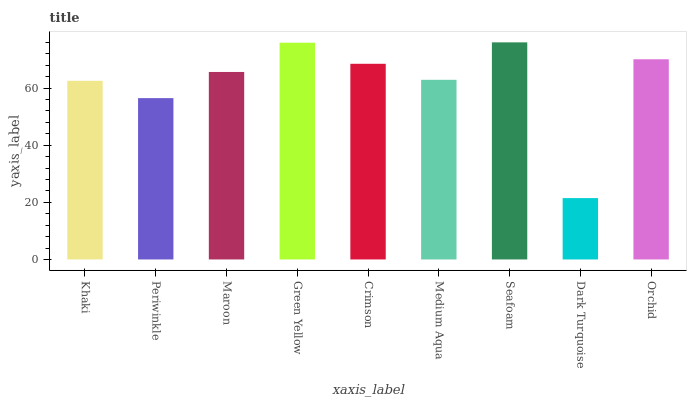Is Dark Turquoise the minimum?
Answer yes or no. Yes. Is Seafoam the maximum?
Answer yes or no. Yes. Is Periwinkle the minimum?
Answer yes or no. No. Is Periwinkle the maximum?
Answer yes or no. No. Is Khaki greater than Periwinkle?
Answer yes or no. Yes. Is Periwinkle less than Khaki?
Answer yes or no. Yes. Is Periwinkle greater than Khaki?
Answer yes or no. No. Is Khaki less than Periwinkle?
Answer yes or no. No. Is Maroon the high median?
Answer yes or no. Yes. Is Maroon the low median?
Answer yes or no. Yes. Is Green Yellow the high median?
Answer yes or no. No. Is Orchid the low median?
Answer yes or no. No. 